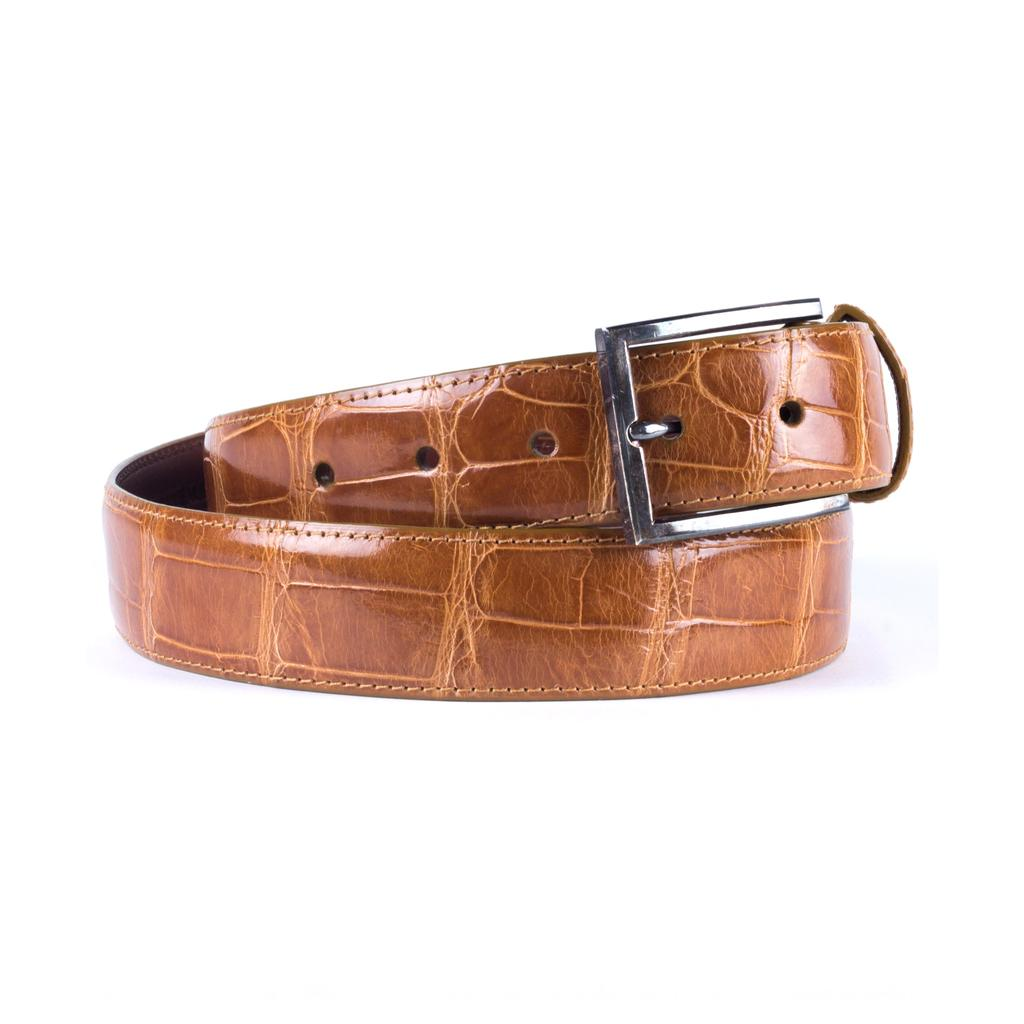What type of accessory is present in the image? There is a leather belt in the image. Can you describe the material of the belt? The belt is made of leather. What word is written on the glass in the image? There is no glass or writing present in the image; it only features a leather belt. 